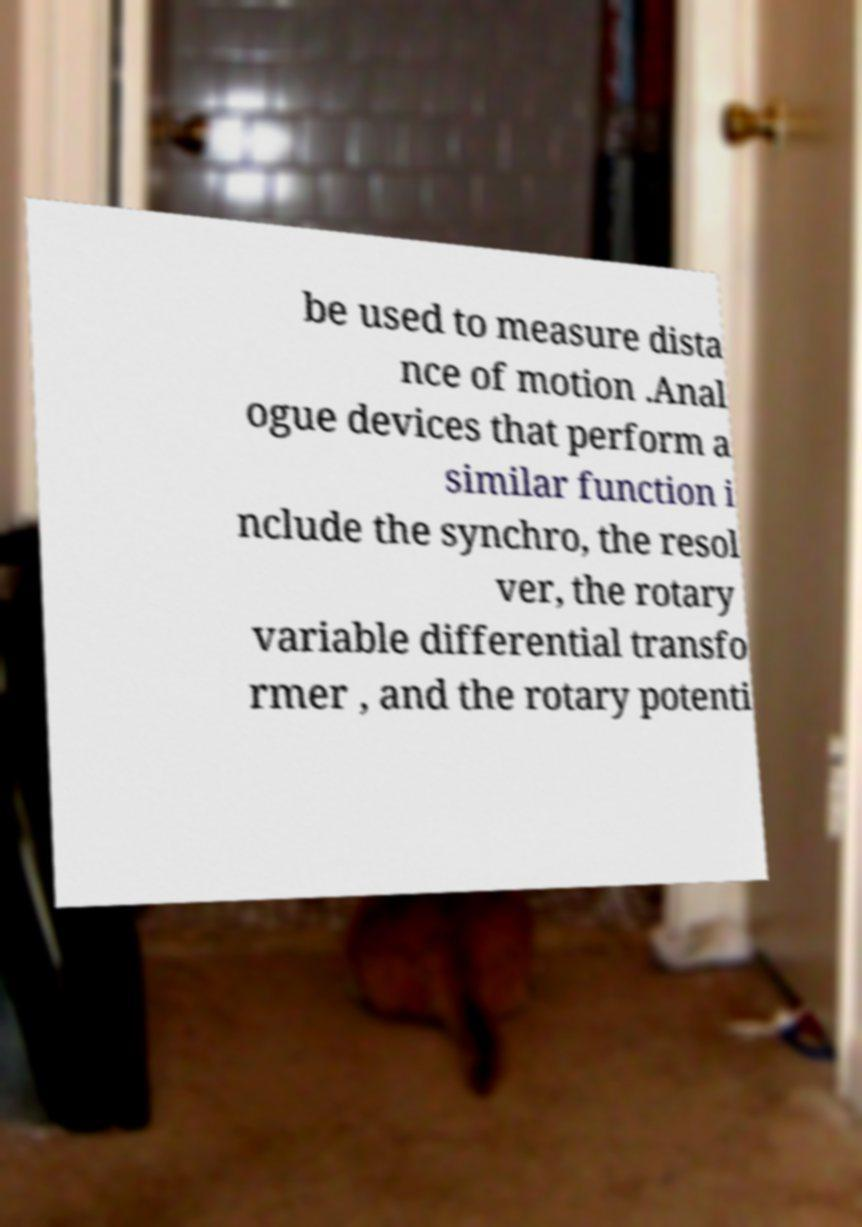Could you assist in decoding the text presented in this image and type it out clearly? be used to measure dista nce of motion .Anal ogue devices that perform a similar function i nclude the synchro, the resol ver, the rotary variable differential transfo rmer , and the rotary potenti 